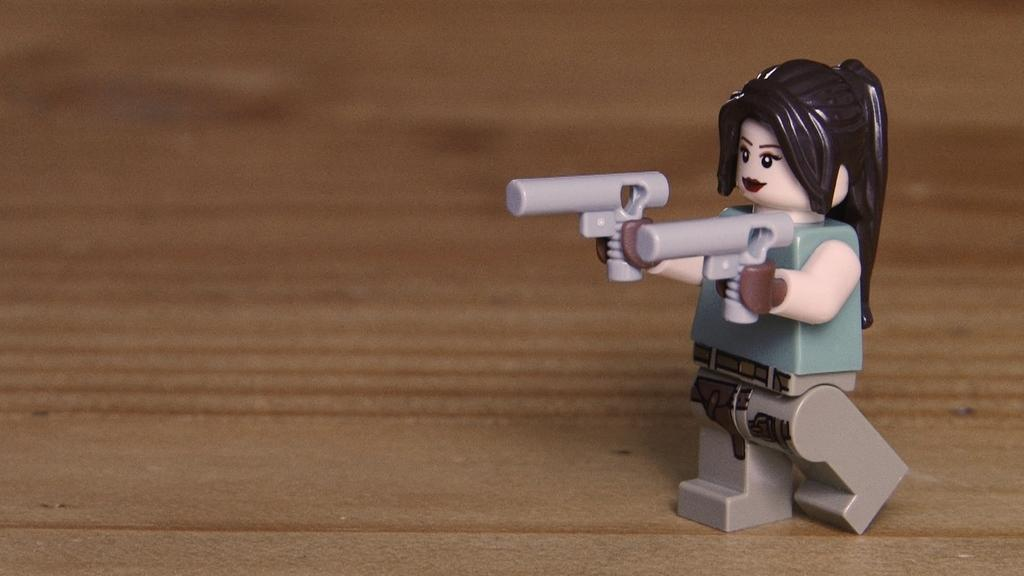What object can be seen in the image? There is a toy in the image. Where is the toy located in the image? The toy is on the right side of the image. What color can be seen in the background of the image? There is brown color visible in the background of the image. What type of prison can be seen in the image? There is no prison present in the image; it features a toy on the right side of the image. What acoustics can be heard in the image? There is no sound or acoustics present in the image, as it is a static visual representation. 